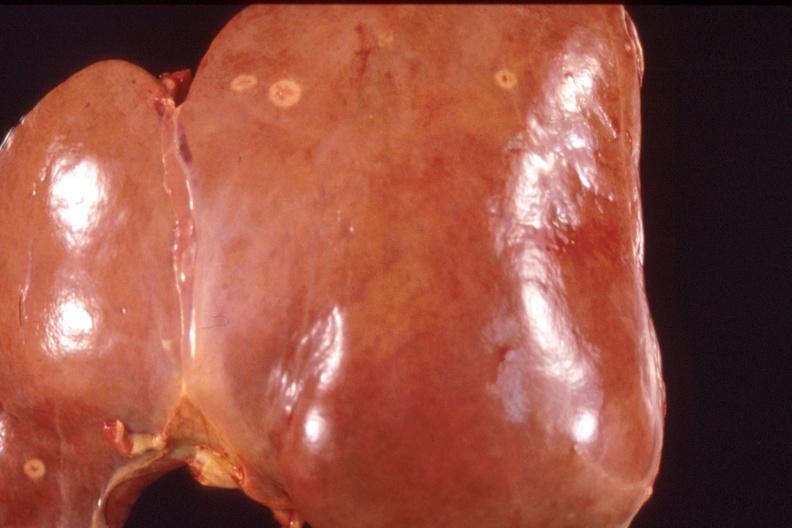does bone, calvarium show liver, metastatic breast cancer?
Answer the question using a single word or phrase. No 